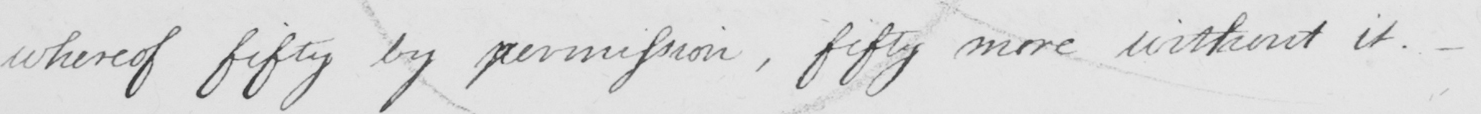What text is written in this handwritten line? whereof fifty by permission , fifty more without it . + 